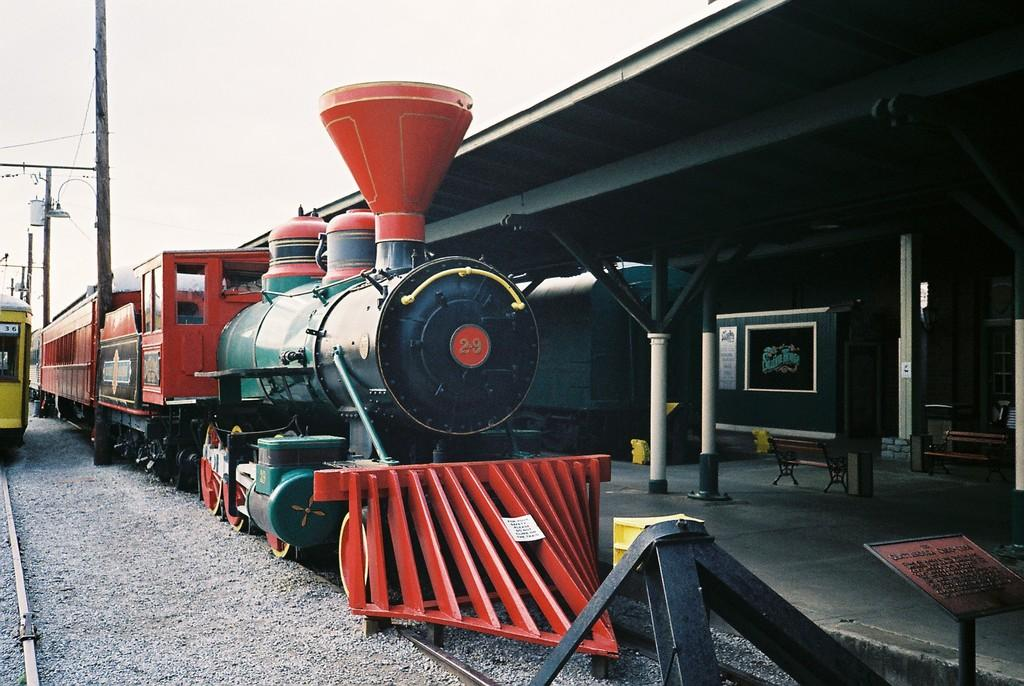What can be seen on the railway tracks in the image? There are trains on the railway tracks in the image. What is located on the right side of the image? There is a platform on the right side of the image. What is visible in the sky in the image? Clouds are visible in the sky in the image. What type of canvas is used to paint the trains in the image? There is no canvas present in the image, as it is a photograph of real trains on railway tracks. How does the taste of the clouds in the image compare to that of cotton candy? The image does not depict the taste of clouds or cotton candy, as it is a photograph of a scene involving trains and a platform. 